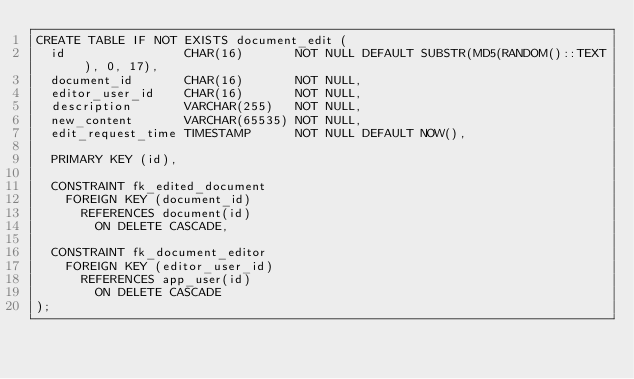<code> <loc_0><loc_0><loc_500><loc_500><_SQL_>CREATE TABLE IF NOT EXISTS document_edit (
  id                CHAR(16)       NOT NULL DEFAULT SUBSTR(MD5(RANDOM()::TEXT), 0, 17),
  document_id       CHAR(16)       NOT NULL,
  editor_user_id    CHAR(16)       NOT NULL,
  description       VARCHAR(255)   NOT NULL,
  new_content       VARCHAR(65535) NOT NULL,
  edit_request_time TIMESTAMP      NOT NULL DEFAULT NOW(),

  PRIMARY KEY (id),

  CONSTRAINT fk_edited_document
    FOREIGN KEY (document_id)
      REFERENCES document(id)
        ON DELETE CASCADE,

  CONSTRAINT fk_document_editor
    FOREIGN KEY (editor_user_id)
      REFERENCES app_user(id)
        ON DELETE CASCADE
);
</code> 